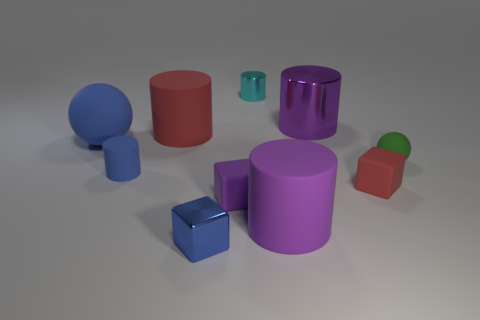Can you tell me about the textures and materials of the objects in this image? Certainly! The objects present a mix of textures and appear to be made from materials with both matte and glossy finishes. The larger cylinder and the cube, for example, have a high-gloss finish that suggests they could be made of plastic or polished stone, while other objects, such as the red cylinder, have a matte surface which might indicate a rubber or unpolished stone material. 